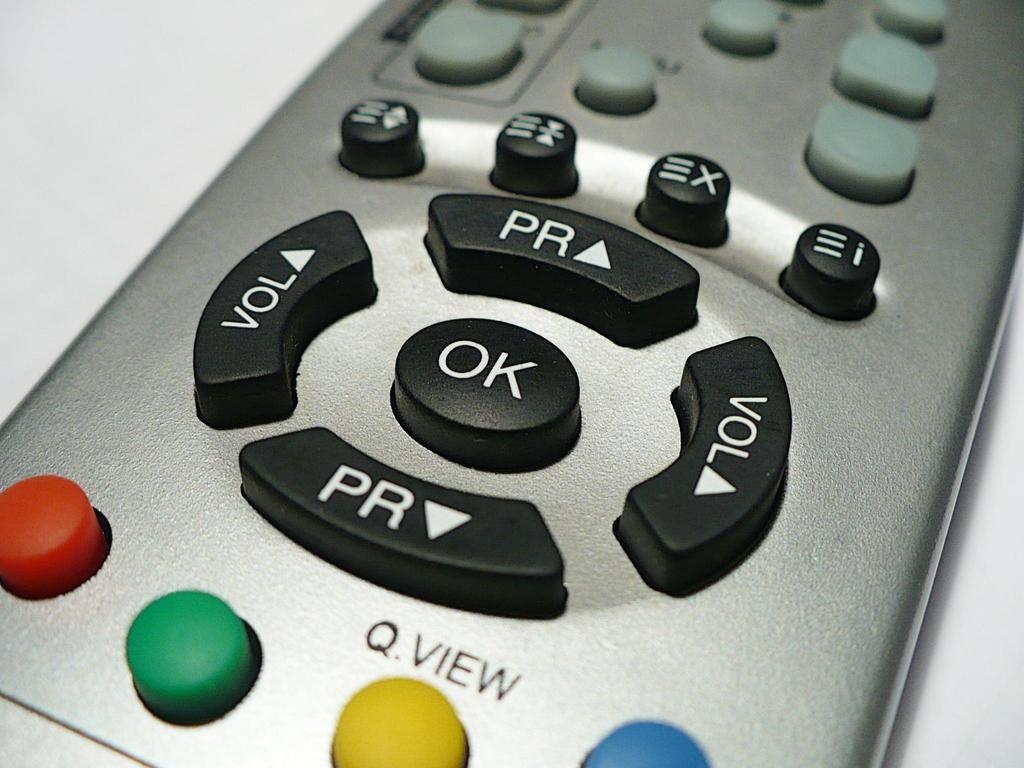What do the buttons on that remote say?
Provide a succinct answer. Ok, vol, pr. What is written above the yellow button?
Your response must be concise. Q.view. 